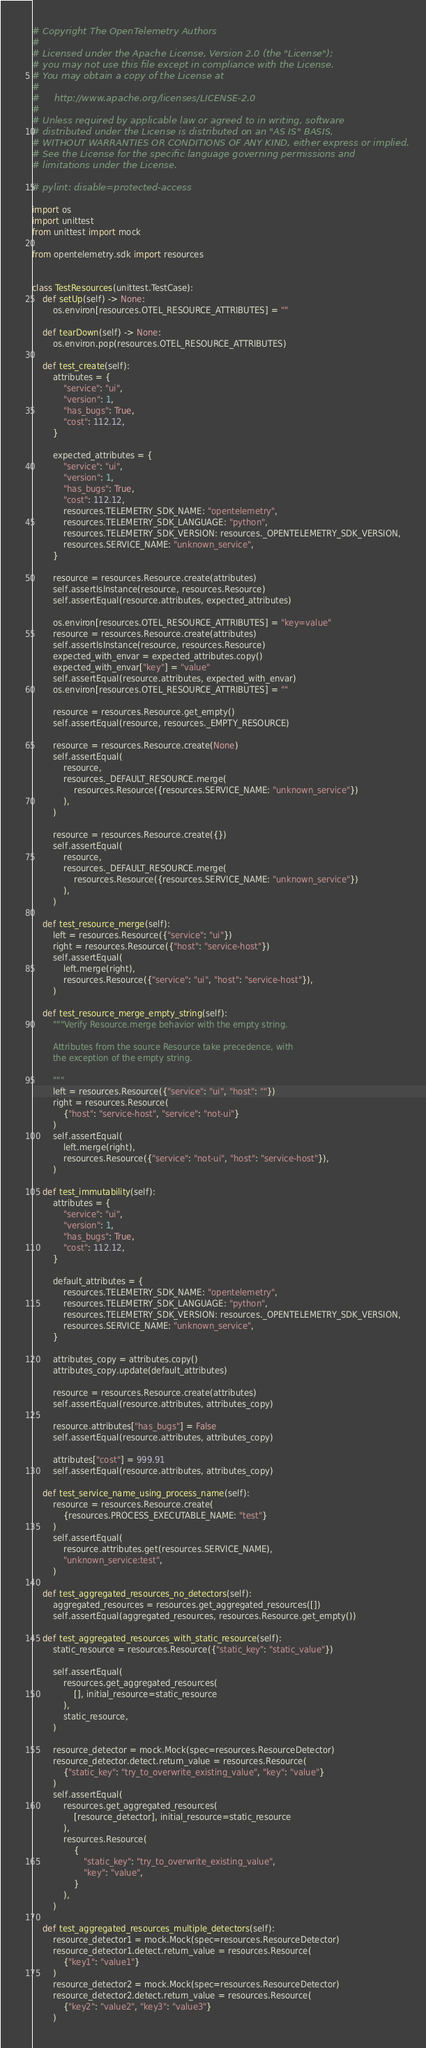<code> <loc_0><loc_0><loc_500><loc_500><_Python_># Copyright The OpenTelemetry Authors
#
# Licensed under the Apache License, Version 2.0 (the "License");
# you may not use this file except in compliance with the License.
# You may obtain a copy of the License at
#
#     http://www.apache.org/licenses/LICENSE-2.0
#
# Unless required by applicable law or agreed to in writing, software
# distributed under the License is distributed on an "AS IS" BASIS,
# WITHOUT WARRANTIES OR CONDITIONS OF ANY KIND, either express or implied.
# See the License for the specific language governing permissions and
# limitations under the License.

# pylint: disable=protected-access

import os
import unittest
from unittest import mock

from opentelemetry.sdk import resources


class TestResources(unittest.TestCase):
    def setUp(self) -> None:
        os.environ[resources.OTEL_RESOURCE_ATTRIBUTES] = ""

    def tearDown(self) -> None:
        os.environ.pop(resources.OTEL_RESOURCE_ATTRIBUTES)

    def test_create(self):
        attributes = {
            "service": "ui",
            "version": 1,
            "has_bugs": True,
            "cost": 112.12,
        }

        expected_attributes = {
            "service": "ui",
            "version": 1,
            "has_bugs": True,
            "cost": 112.12,
            resources.TELEMETRY_SDK_NAME: "opentelemetry",
            resources.TELEMETRY_SDK_LANGUAGE: "python",
            resources.TELEMETRY_SDK_VERSION: resources._OPENTELEMETRY_SDK_VERSION,
            resources.SERVICE_NAME: "unknown_service",
        }

        resource = resources.Resource.create(attributes)
        self.assertIsInstance(resource, resources.Resource)
        self.assertEqual(resource.attributes, expected_attributes)

        os.environ[resources.OTEL_RESOURCE_ATTRIBUTES] = "key=value"
        resource = resources.Resource.create(attributes)
        self.assertIsInstance(resource, resources.Resource)
        expected_with_envar = expected_attributes.copy()
        expected_with_envar["key"] = "value"
        self.assertEqual(resource.attributes, expected_with_envar)
        os.environ[resources.OTEL_RESOURCE_ATTRIBUTES] = ""

        resource = resources.Resource.get_empty()
        self.assertEqual(resource, resources._EMPTY_RESOURCE)

        resource = resources.Resource.create(None)
        self.assertEqual(
            resource,
            resources._DEFAULT_RESOURCE.merge(
                resources.Resource({resources.SERVICE_NAME: "unknown_service"})
            ),
        )

        resource = resources.Resource.create({})
        self.assertEqual(
            resource,
            resources._DEFAULT_RESOURCE.merge(
                resources.Resource({resources.SERVICE_NAME: "unknown_service"})
            ),
        )

    def test_resource_merge(self):
        left = resources.Resource({"service": "ui"})
        right = resources.Resource({"host": "service-host"})
        self.assertEqual(
            left.merge(right),
            resources.Resource({"service": "ui", "host": "service-host"}),
        )

    def test_resource_merge_empty_string(self):
        """Verify Resource.merge behavior with the empty string.

        Attributes from the source Resource take precedence, with
        the exception of the empty string.

        """
        left = resources.Resource({"service": "ui", "host": ""})
        right = resources.Resource(
            {"host": "service-host", "service": "not-ui"}
        )
        self.assertEqual(
            left.merge(right),
            resources.Resource({"service": "not-ui", "host": "service-host"}),
        )

    def test_immutability(self):
        attributes = {
            "service": "ui",
            "version": 1,
            "has_bugs": True,
            "cost": 112.12,
        }

        default_attributes = {
            resources.TELEMETRY_SDK_NAME: "opentelemetry",
            resources.TELEMETRY_SDK_LANGUAGE: "python",
            resources.TELEMETRY_SDK_VERSION: resources._OPENTELEMETRY_SDK_VERSION,
            resources.SERVICE_NAME: "unknown_service",
        }

        attributes_copy = attributes.copy()
        attributes_copy.update(default_attributes)

        resource = resources.Resource.create(attributes)
        self.assertEqual(resource.attributes, attributes_copy)

        resource.attributes["has_bugs"] = False
        self.assertEqual(resource.attributes, attributes_copy)

        attributes["cost"] = 999.91
        self.assertEqual(resource.attributes, attributes_copy)

    def test_service_name_using_process_name(self):
        resource = resources.Resource.create(
            {resources.PROCESS_EXECUTABLE_NAME: "test"}
        )
        self.assertEqual(
            resource.attributes.get(resources.SERVICE_NAME),
            "unknown_service:test",
        )

    def test_aggregated_resources_no_detectors(self):
        aggregated_resources = resources.get_aggregated_resources([])
        self.assertEqual(aggregated_resources, resources.Resource.get_empty())

    def test_aggregated_resources_with_static_resource(self):
        static_resource = resources.Resource({"static_key": "static_value"})

        self.assertEqual(
            resources.get_aggregated_resources(
                [], initial_resource=static_resource
            ),
            static_resource,
        )

        resource_detector = mock.Mock(spec=resources.ResourceDetector)
        resource_detector.detect.return_value = resources.Resource(
            {"static_key": "try_to_overwrite_existing_value", "key": "value"}
        )
        self.assertEqual(
            resources.get_aggregated_resources(
                [resource_detector], initial_resource=static_resource
            ),
            resources.Resource(
                {
                    "static_key": "try_to_overwrite_existing_value",
                    "key": "value",
                }
            ),
        )

    def test_aggregated_resources_multiple_detectors(self):
        resource_detector1 = mock.Mock(spec=resources.ResourceDetector)
        resource_detector1.detect.return_value = resources.Resource(
            {"key1": "value1"}
        )
        resource_detector2 = mock.Mock(spec=resources.ResourceDetector)
        resource_detector2.detect.return_value = resources.Resource(
            {"key2": "value2", "key3": "value3"}
        )</code> 